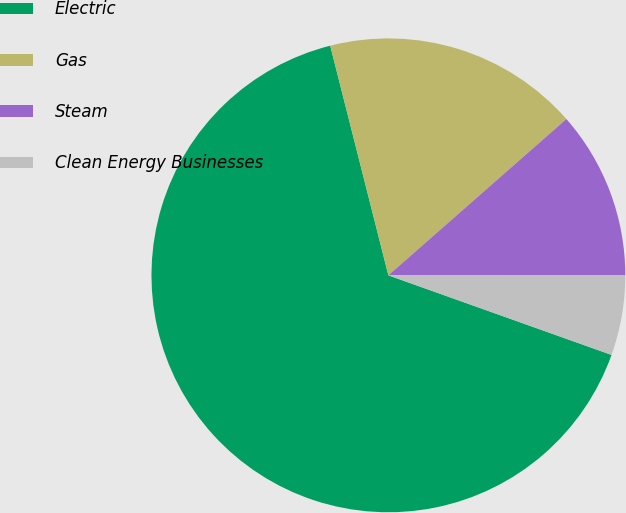<chart> <loc_0><loc_0><loc_500><loc_500><pie_chart><fcel>Electric<fcel>Gas<fcel>Steam<fcel>Clean Energy Businesses<nl><fcel>65.6%<fcel>17.48%<fcel>11.47%<fcel>5.45%<nl></chart> 